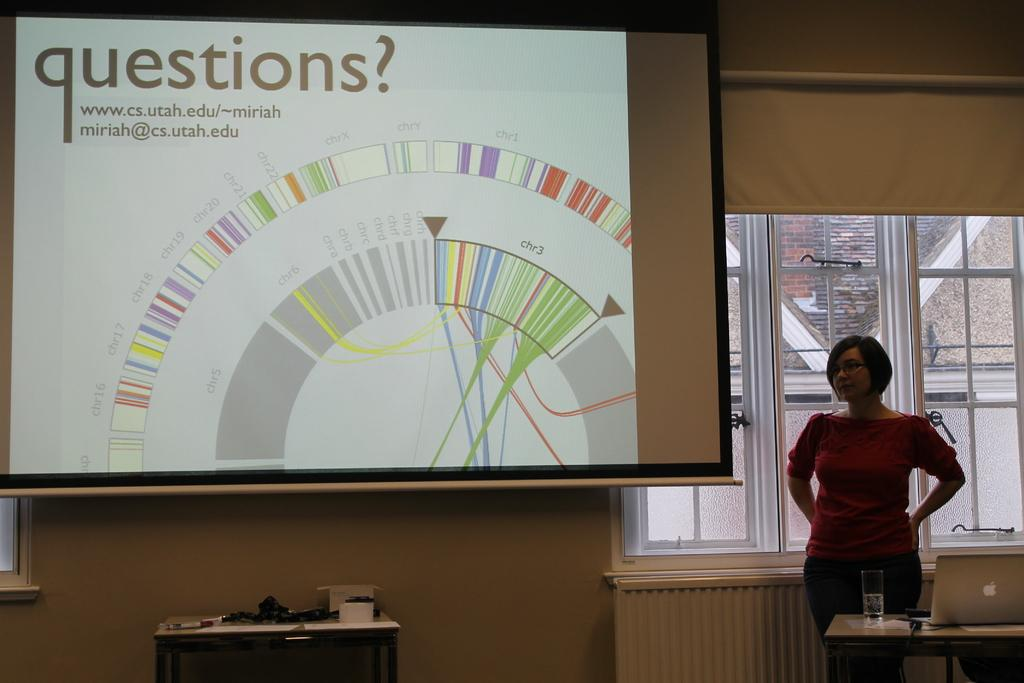What is the primary subject in the image? There is a woman standing in the image. Where is the woman standing? The woman is standing on the floor. What can be seen on the table in the image? A laptop and a glass are present on the table, along with other objects. What is visible in the background of the image? There is a screen, a wall, and windows in the background of the image. How many women are copying the laptop screen in the image? There is only one woman in the image, and she is not copying the laptop screen. Can you see any bees flying around the woman in the image? There are no bees present in the image. 